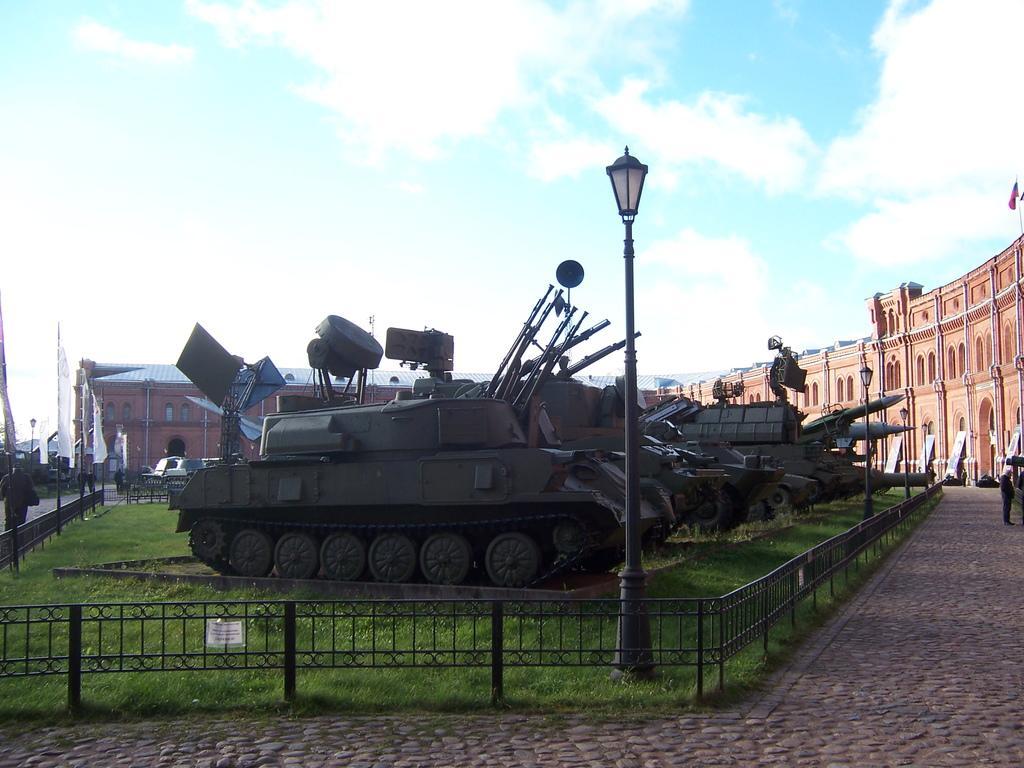Can you describe this image briefly? In the center of the image we can see war tankers on the grass. At the bottom of the image we can see fencing. On the right side of the image we can see building. On the left side of the image we can see flags and building. In the background we can see sky and clouds. 